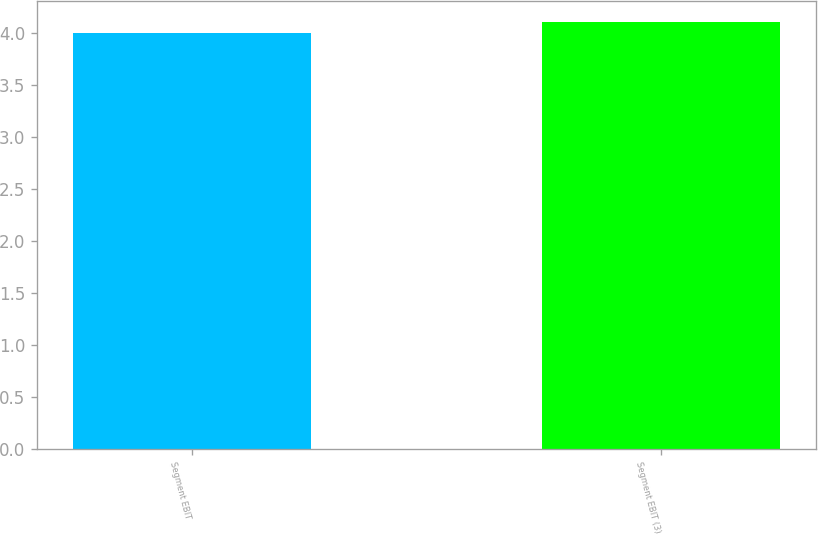<chart> <loc_0><loc_0><loc_500><loc_500><bar_chart><fcel>Segment EBIT<fcel>Segment EBIT (3)<nl><fcel>4<fcel>4.1<nl></chart> 